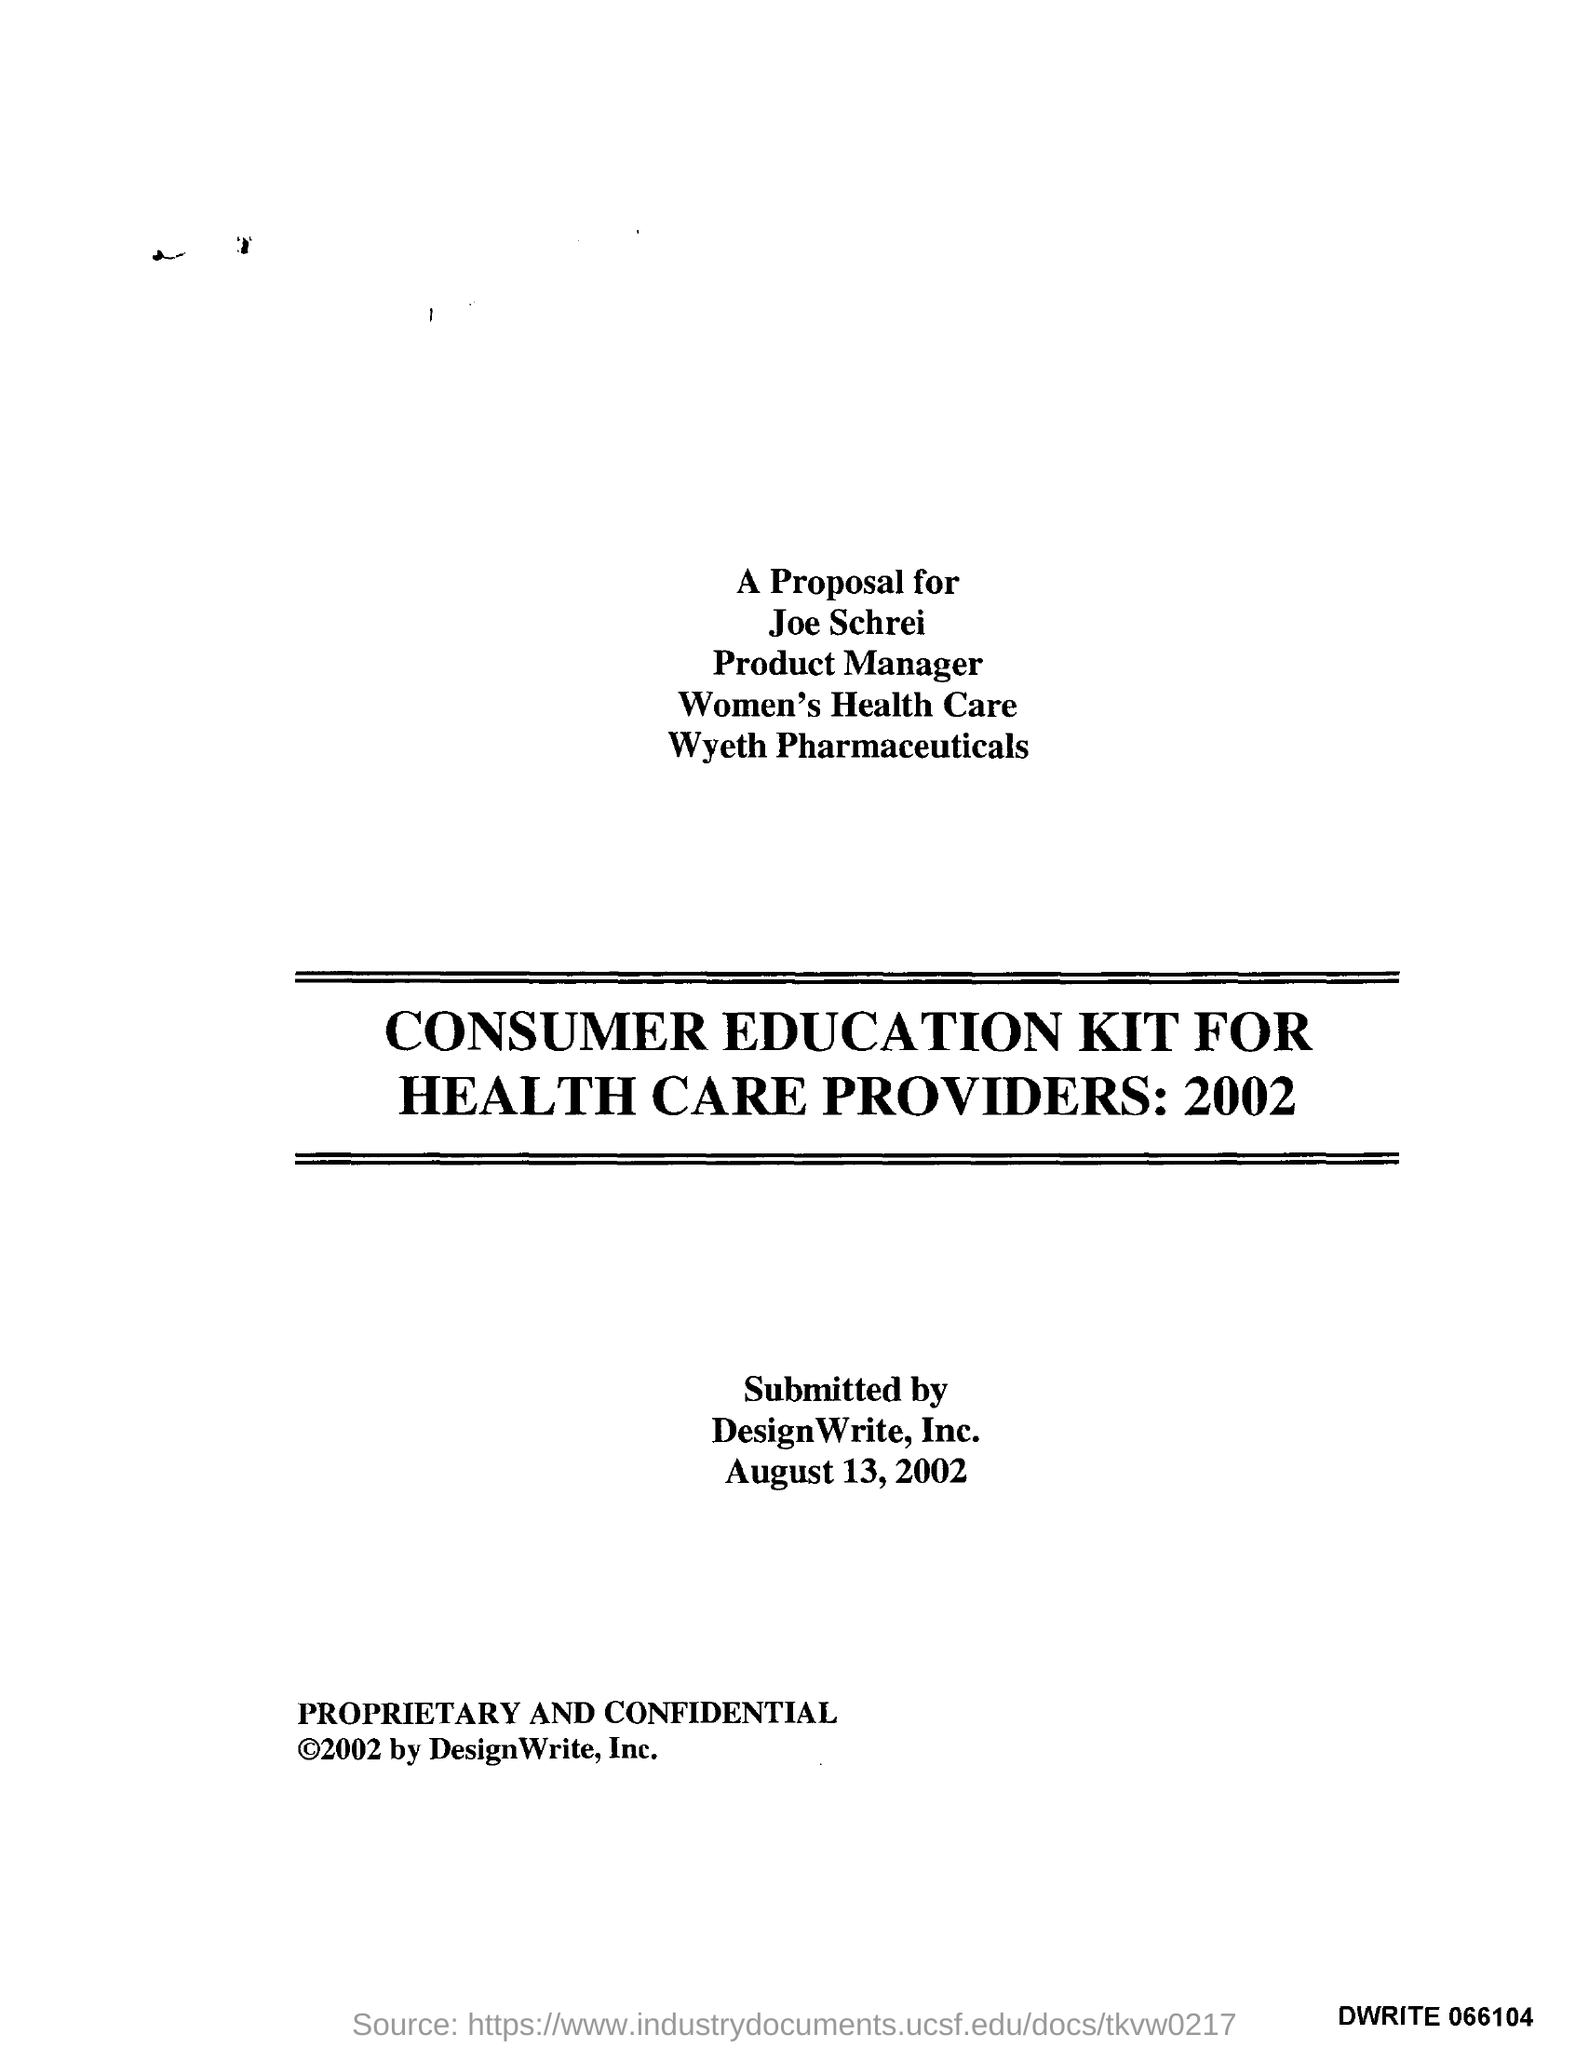Point out several critical features in this image. This proposal is directed to Joe Schreiber. Wyeth Pharmaceuticals is the name of the pharmaceutical company. 